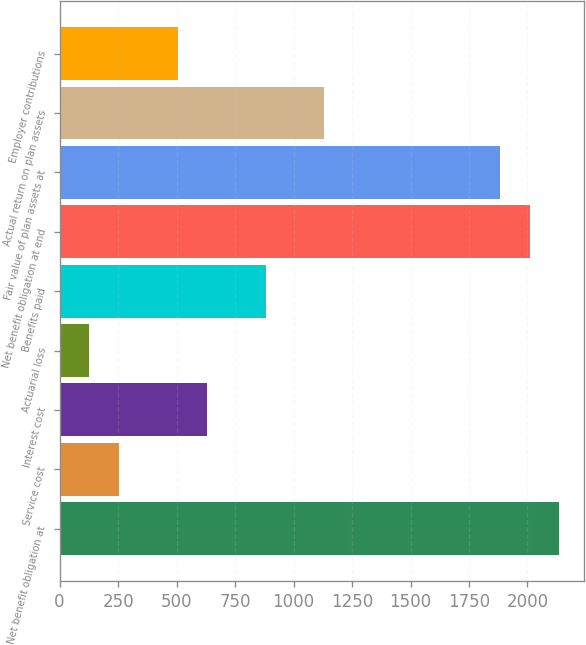Convert chart to OTSL. <chart><loc_0><loc_0><loc_500><loc_500><bar_chart><fcel>Net benefit obligation at<fcel>Service cost<fcel>Interest cost<fcel>Actuarial loss<fcel>Benefits paid<fcel>Net benefit obligation at end<fcel>Fair value of plan assets at<fcel>Actual return on plan assets<fcel>Employer contributions<nl><fcel>2135.5<fcel>253<fcel>629.5<fcel>127.5<fcel>880.5<fcel>2010<fcel>1884.5<fcel>1131.5<fcel>504<nl></chart> 